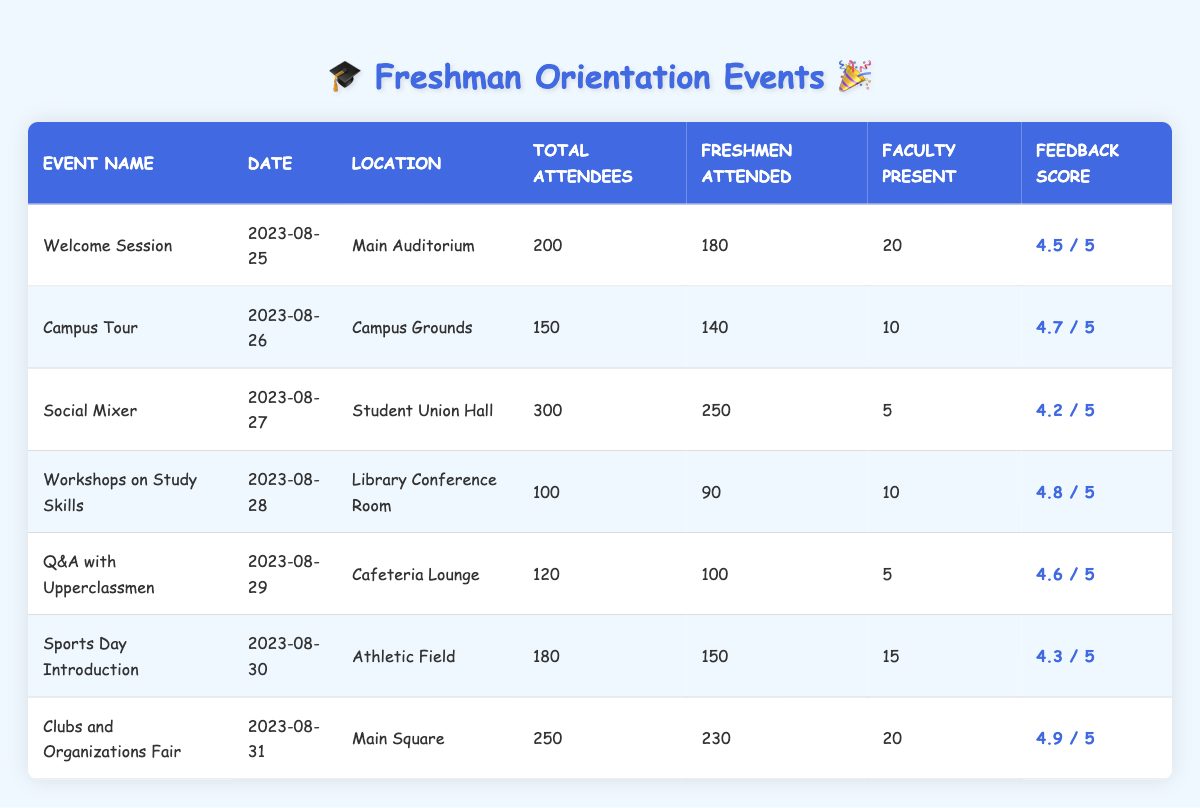What was the highest feedback score among the events? By looking at the feedback score column, the values are 4.5, 4.7, 4.2, 4.8, 4.6, 4.3, and 4.9. The highest score is 4.9 from the "Clubs and Organizations Fair" event.
Answer: 4.9 How many freshmen attended the 'Social Mixer'? The 'Social Mixer' event had 250 freshmen attending, as shown in the freshmen attended column for that event.
Answer: 250 Which event had the least total attendees? The event with the least total attendees is "Workshops on Study Skills," which had only 100 total attendees, as per the total attendees column.
Answer: 100 What is the average number of freshmen who attended the events? To find the average, add the freshmen attended values: 180 + 140 + 250 + 90 + 100 + 150 + 230 = 1140. Then divide by the number of events (7): 1140 / 7 = 162.86.
Answer: 162.86 Did more freshmen attend "Campus Tour" or "Workshops on Study Skills"? The "Campus Tour" had 140 freshmen, while "Workshops on Study Skills" had 90 freshmen. Therefore, more freshmen attended the "Campus Tour."
Answer: Yes How many total attendees were there across all events? The total number of attendees for all events is the sum of the total attendees: 200 + 150 + 300 + 100 + 120 + 180 + 250 = 1300.
Answer: 1300 What percentage of total attendees were freshmen at the "Q&A with Upperclassmen" event? The "Q&A with Upperclassmen" had 100 freshmen out of 120 total attendees. To find the percentage, divide 100 by 120 and multiply by 100: (100/120) * 100 = 83.33%.
Answer: 83.33% Which event had the most faculty present? By checking the faculty present column, "Welcome Session" had 20 faculty members present, which is the highest compared to the other events.
Answer: 20 If we compare the feedback scores of the 'Sports Day Introduction' and 'Workshops on Study Skills', what is the difference in their scores? The feedback score for 'Sports Day Introduction' is 4.3 and for 'Workshops on Study Skills' is 4.8. The difference is 4.8 - 4.3 = 0.5.
Answer: 0.5 Which event had the highest number of freshmen compared to total attendees? 'Clubs and Organizations Fair' had 230 freshmen out of 250 total. To find the highest proportion, calculate the ratio: 230/250 = 0.92.  'Social Mixer' is next with 250/300 = 0.83. Thus, 'Clubs and Organizations Fair' has the highest ratio.
Answer: Clubs and Organizations Fair 